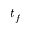Convert formula to latex. <formula><loc_0><loc_0><loc_500><loc_500>t _ { f }</formula> 